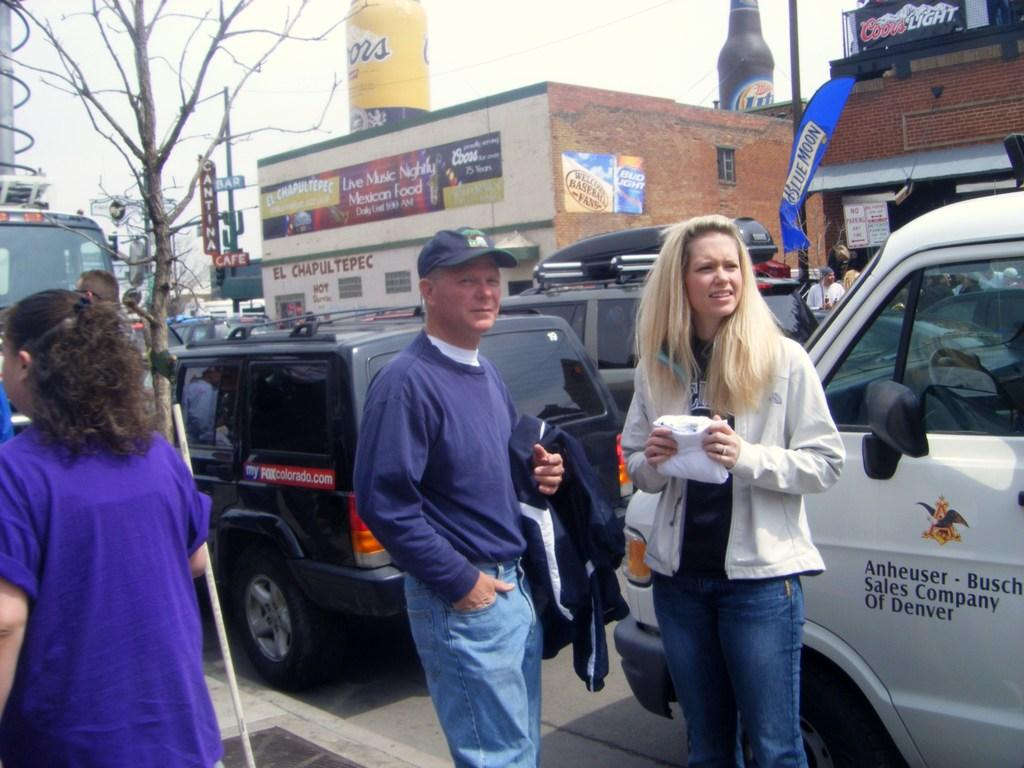<image>
Write a terse but informative summary of the picture. A man and woman stand on the sidewalk beside an Anheuser and Busch sales company truck. 